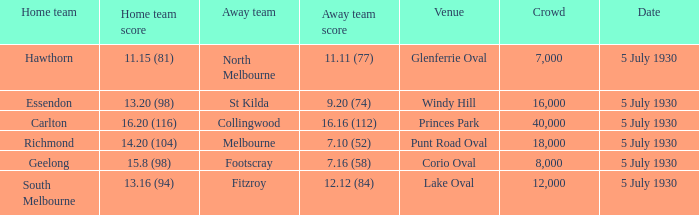What day is the team's match at punt road oval? 5 July 1930. 